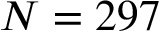<formula> <loc_0><loc_0><loc_500><loc_500>N = 2 9 7</formula> 